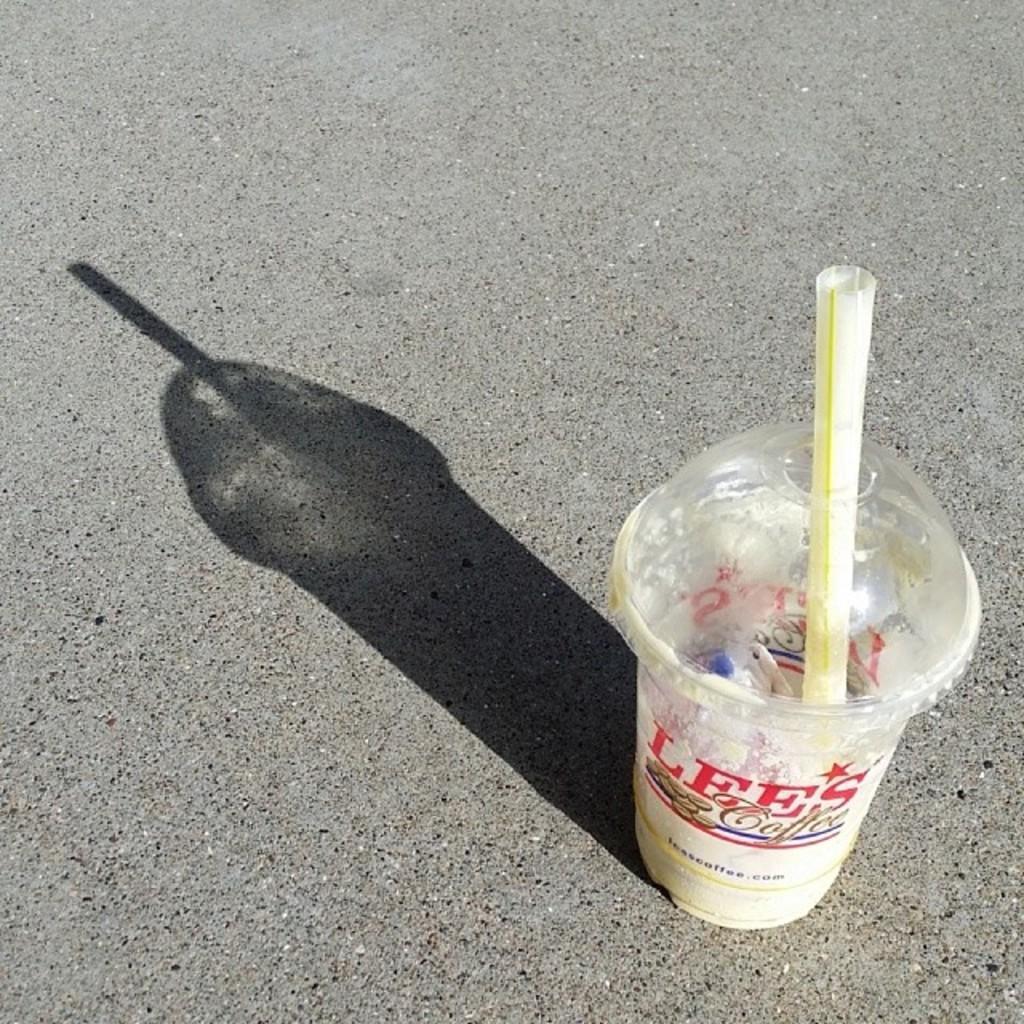In one or two sentences, can you explain what this image depicts? In this image we can see a disposable tumbler with straw in it placed on the floor. 